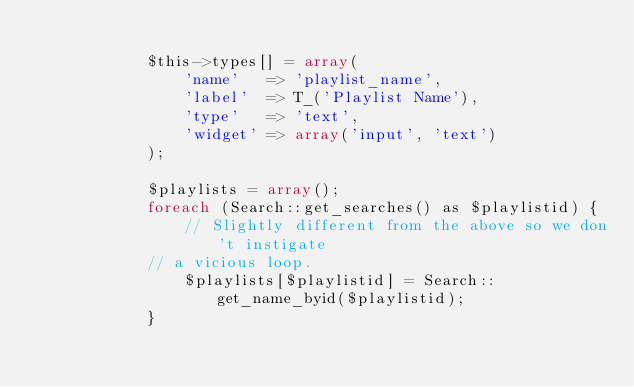<code> <loc_0><loc_0><loc_500><loc_500><_PHP_>
            $this->types[] = array(
                'name'   => 'playlist_name',
                'label'  => T_('Playlist Name'),
                'type'   => 'text',
                'widget' => array('input', 'text')
            );

            $playlists = array();
            foreach (Search::get_searches() as $playlistid) {
                // Slightly different from the above so we don't instigate
            // a vicious loop.
                $playlists[$playlistid] = Search::get_name_byid($playlistid);
            }</code> 